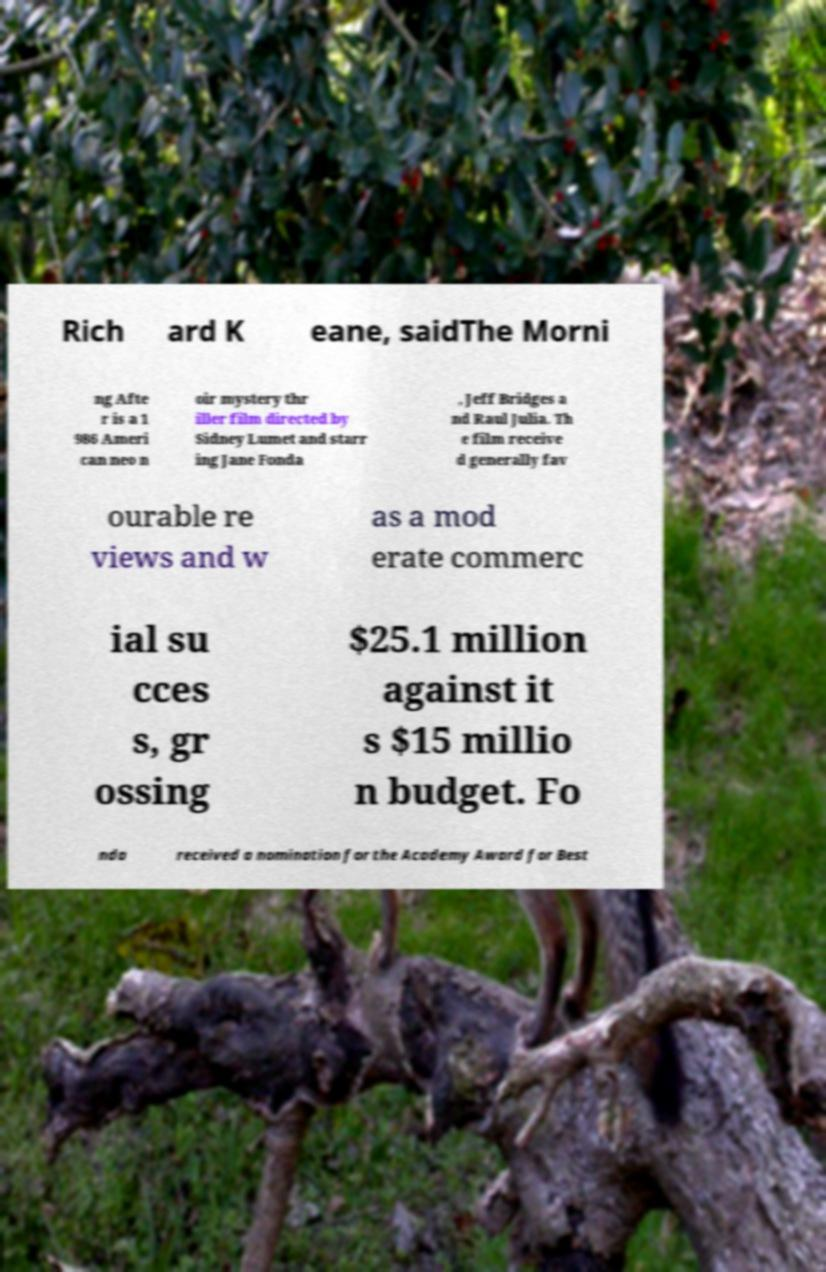I need the written content from this picture converted into text. Can you do that? Rich ard K eane, saidThe Morni ng Afte r is a 1 986 Ameri can neo n oir mystery thr iller film directed by Sidney Lumet and starr ing Jane Fonda , Jeff Bridges a nd Raul Julia. Th e film receive d generally fav ourable re views and w as a mod erate commerc ial su cces s, gr ossing $25.1 million against it s $15 millio n budget. Fo nda received a nomination for the Academy Award for Best 